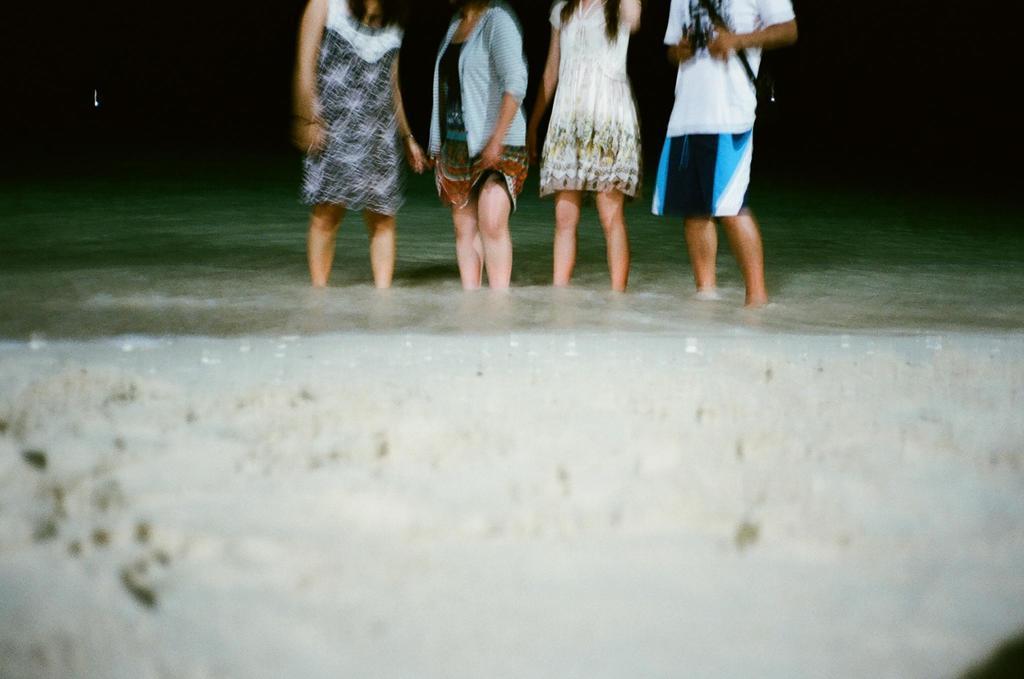Could you give a brief overview of what you see in this image? In this image I can see four persons are standing in the water. This image is taken may be in the water during night. 